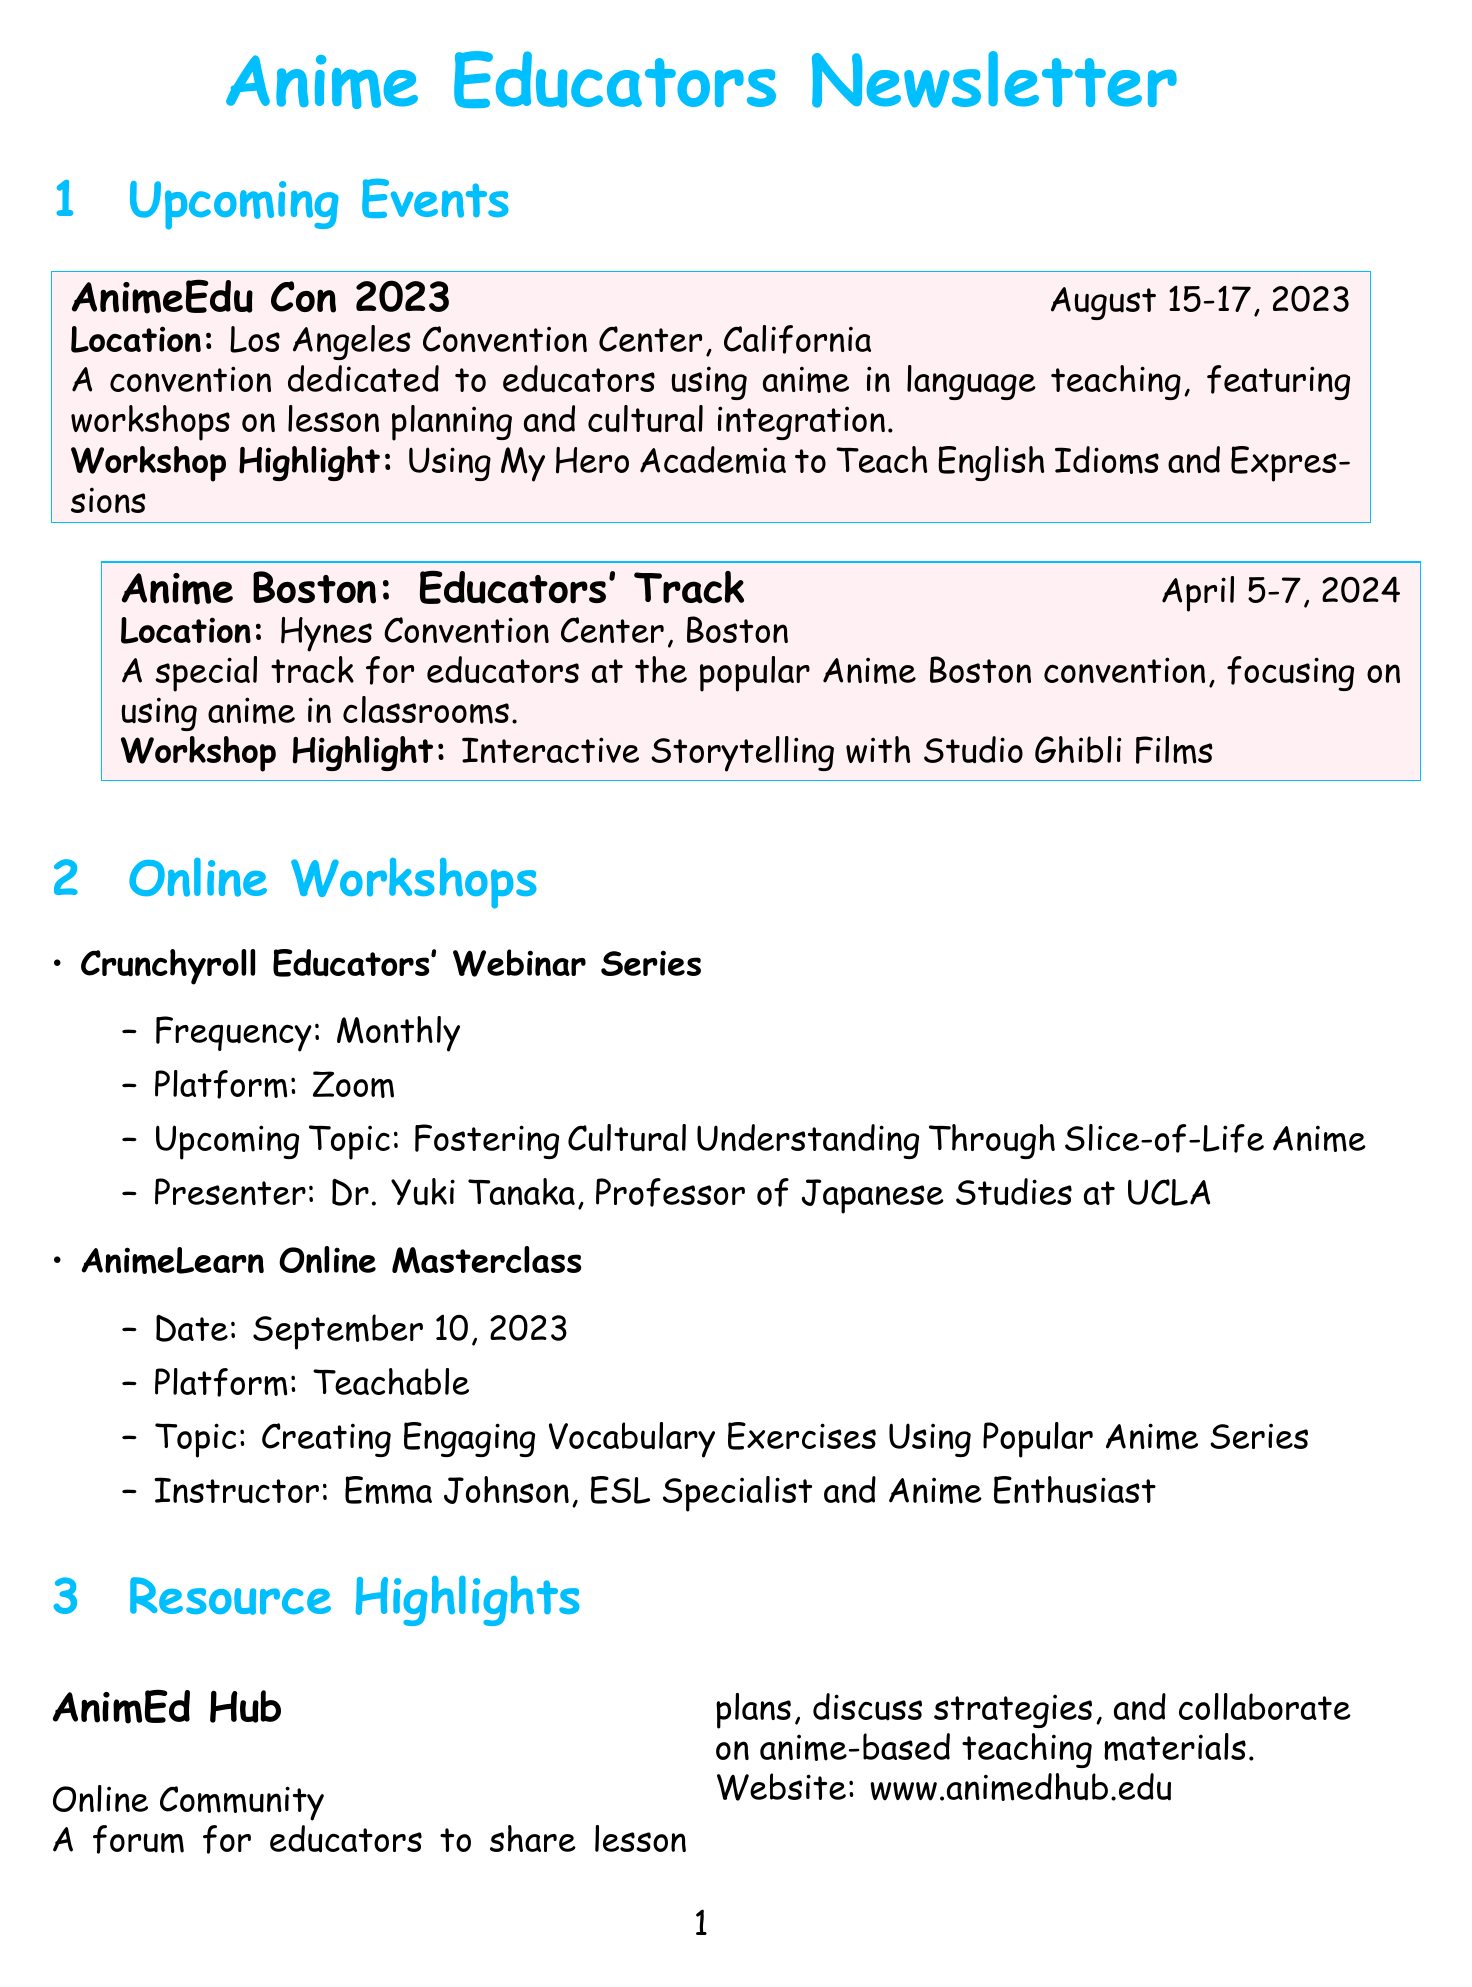What is the date of AnimeEdu Con 2023? The date is specifically mentioned in the document for AnimeEdu Con 2023 as August 15-17, 2023.
Answer: August 15-17, 2023 Where will Anime Boston take place? The location for Anime Boston is stated in the document as Hynes Convention Center, Boston.
Answer: Hynes Convention Center, Boston Who is the presenter of the Crunchyroll Educators' Webinar Series? The document lists Dr. Yuki Tanaka as the presenter for the Crunchyroll Educators' Webinar Series.
Answer: Dr. Yuki Tanaka What is the highlight workshop for AnimeEdu Con 2023? The document specifies the workshop highlight for AnimeEdu Con 2023 as "Using My Hero Academia to Teach English Idioms and Expressions."
Answer: Using My Hero Academia to Teach English Idioms and Expressions When will the AnimeLearn Online Masterclass occur? The date for the AnimeLearn Online Masterclass is mentioned as September 10, 2023.
Answer: September 10, 2023 Which anime is suggested for listening comprehension exercises? The three anime suggested for listening comprehension exercises are mentioned in the document as Naruto, One Piece, and Attack on Titan.
Answer: Naruto, One Piece, Attack on Titan What type of resource is AnimEd Hub? The document categorizes AnimEd Hub as an online community for educators.
Answer: Online Community How often is the Crunchyroll Educators' Webinar Series held? The document states that the Crunchyroll Educators' Webinar Series is held monthly.
Answer: Monthly What is the title of Dr. Michael Chen's e-book? The title of the e-book authored by Dr. Michael Chen is "Anime in the Classroom: A Comprehensive Guide."
Answer: Anime in the Classroom: A Comprehensive Guide 